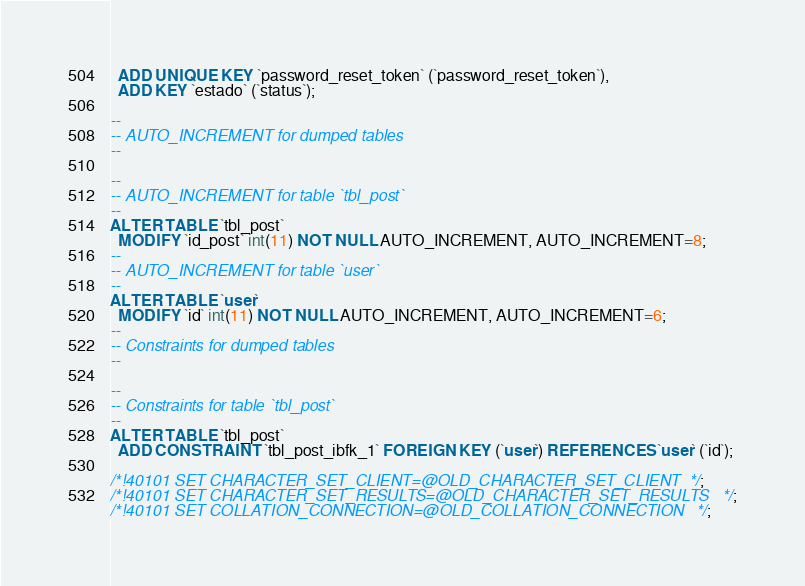Convert code to text. <code><loc_0><loc_0><loc_500><loc_500><_SQL_>  ADD UNIQUE KEY `password_reset_token` (`password_reset_token`),
  ADD KEY `estado` (`status`);

--
-- AUTO_INCREMENT for dumped tables
--

--
-- AUTO_INCREMENT for table `tbl_post`
--
ALTER TABLE `tbl_post`
  MODIFY `id_post` int(11) NOT NULL AUTO_INCREMENT, AUTO_INCREMENT=8;
--
-- AUTO_INCREMENT for table `user`
--
ALTER TABLE `user`
  MODIFY `id` int(11) NOT NULL AUTO_INCREMENT, AUTO_INCREMENT=6;
--
-- Constraints for dumped tables
--

--
-- Constraints for table `tbl_post`
--
ALTER TABLE `tbl_post`
  ADD CONSTRAINT `tbl_post_ibfk_1` FOREIGN KEY (`user`) REFERENCES `user` (`id`);

/*!40101 SET CHARACTER_SET_CLIENT=@OLD_CHARACTER_SET_CLIENT */;
/*!40101 SET CHARACTER_SET_RESULTS=@OLD_CHARACTER_SET_RESULTS */;
/*!40101 SET COLLATION_CONNECTION=@OLD_COLLATION_CONNECTION */;
</code> 